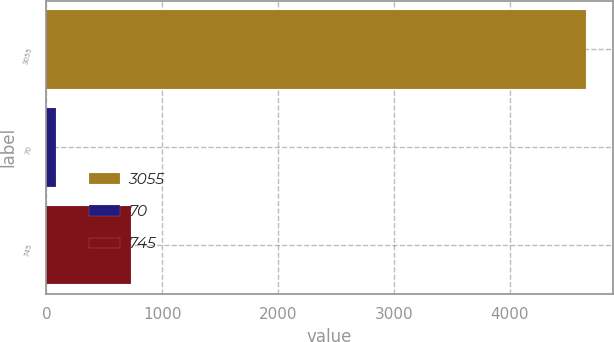Convert chart. <chart><loc_0><loc_0><loc_500><loc_500><bar_chart><fcel>3055<fcel>70<fcel>745<nl><fcel>4658<fcel>80<fcel>733<nl></chart> 